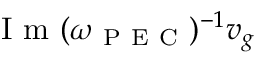Convert formula to latex. <formula><loc_0><loc_0><loc_500><loc_500>I m ( \omega _ { P E C } ) ^ { - 1 } v _ { g }</formula> 